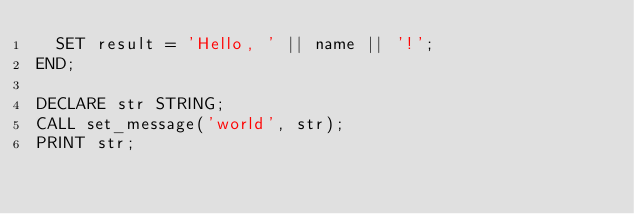<code> <loc_0><loc_0><loc_500><loc_500><_SQL_>  SET result = 'Hello, ' || name || '!';
END;
 
DECLARE str STRING;
CALL set_message('world', str);
PRINT str;

</code> 